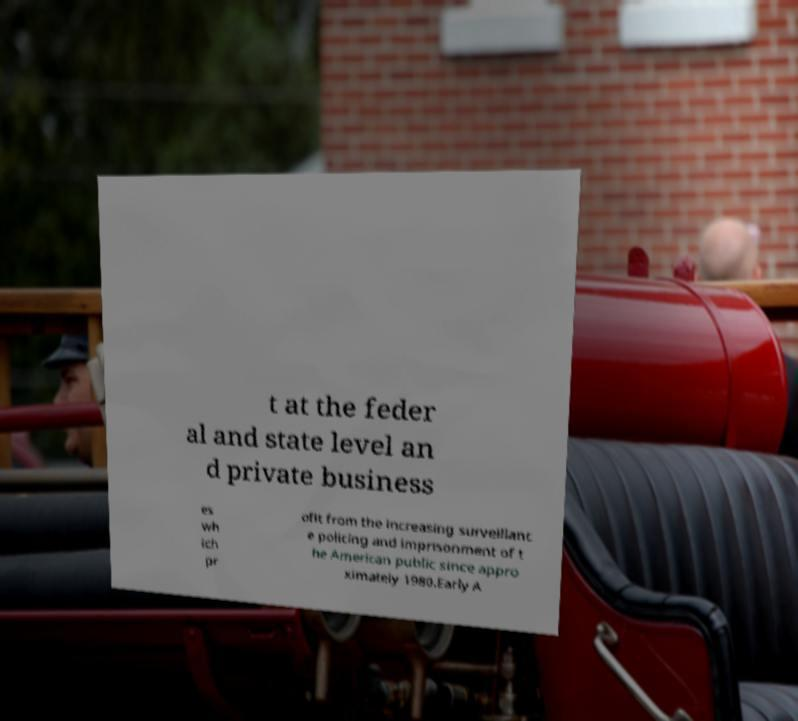Could you assist in decoding the text presented in this image and type it out clearly? t at the feder al and state level an d private business es wh ich pr ofit from the increasing surveillanc e policing and imprisonment of t he American public since appro ximately 1980.Early A 